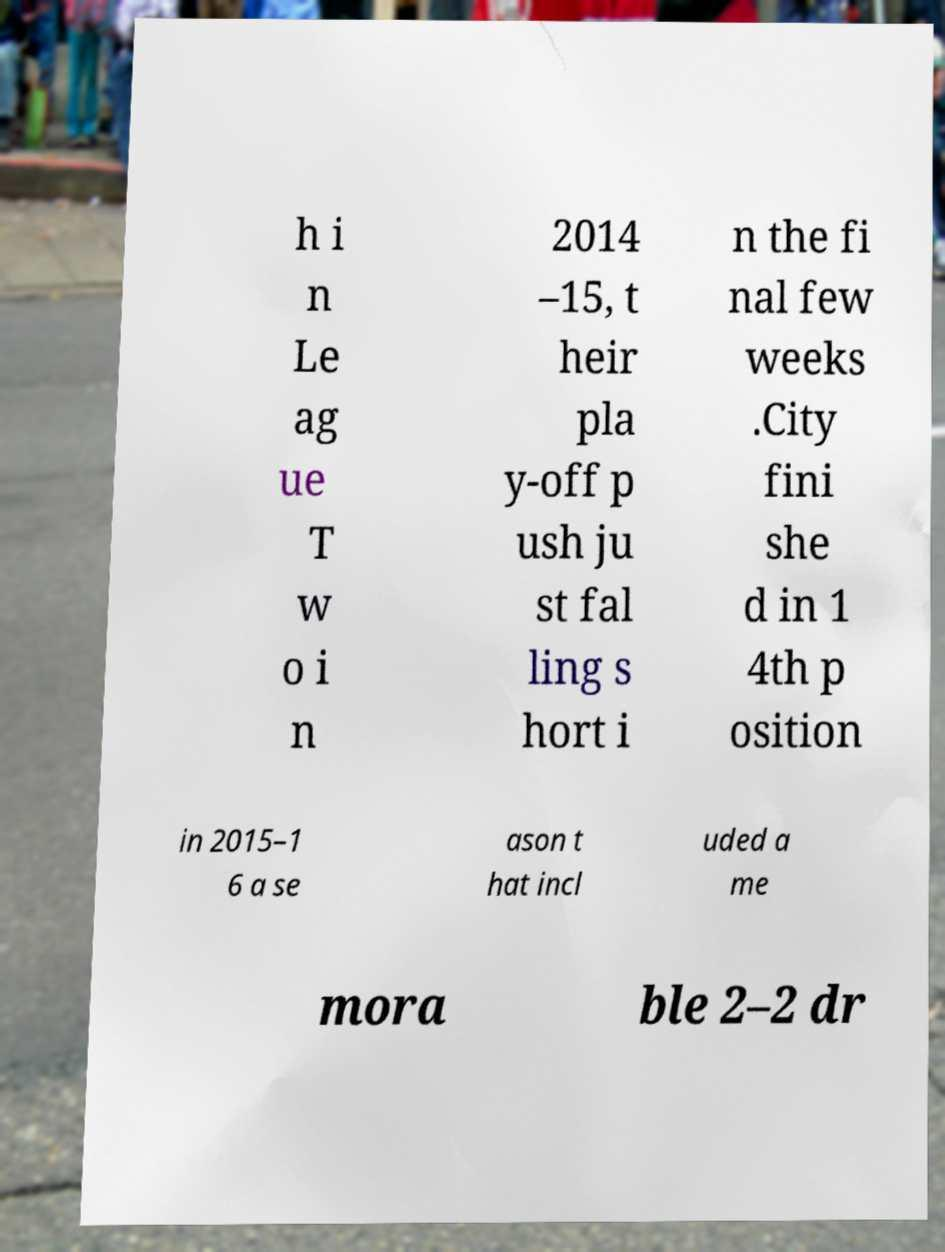What messages or text are displayed in this image? I need them in a readable, typed format. h i n Le ag ue T w o i n 2014 –15, t heir pla y-off p ush ju st fal ling s hort i n the fi nal few weeks .City fini she d in 1 4th p osition in 2015–1 6 a se ason t hat incl uded a me mora ble 2–2 dr 